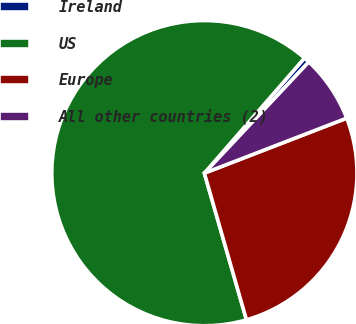Convert chart. <chart><loc_0><loc_0><loc_500><loc_500><pie_chart><fcel>Ireland<fcel>US<fcel>Europe<fcel>All other countries (2)<nl><fcel>0.61%<fcel>65.83%<fcel>26.42%<fcel>7.13%<nl></chart> 